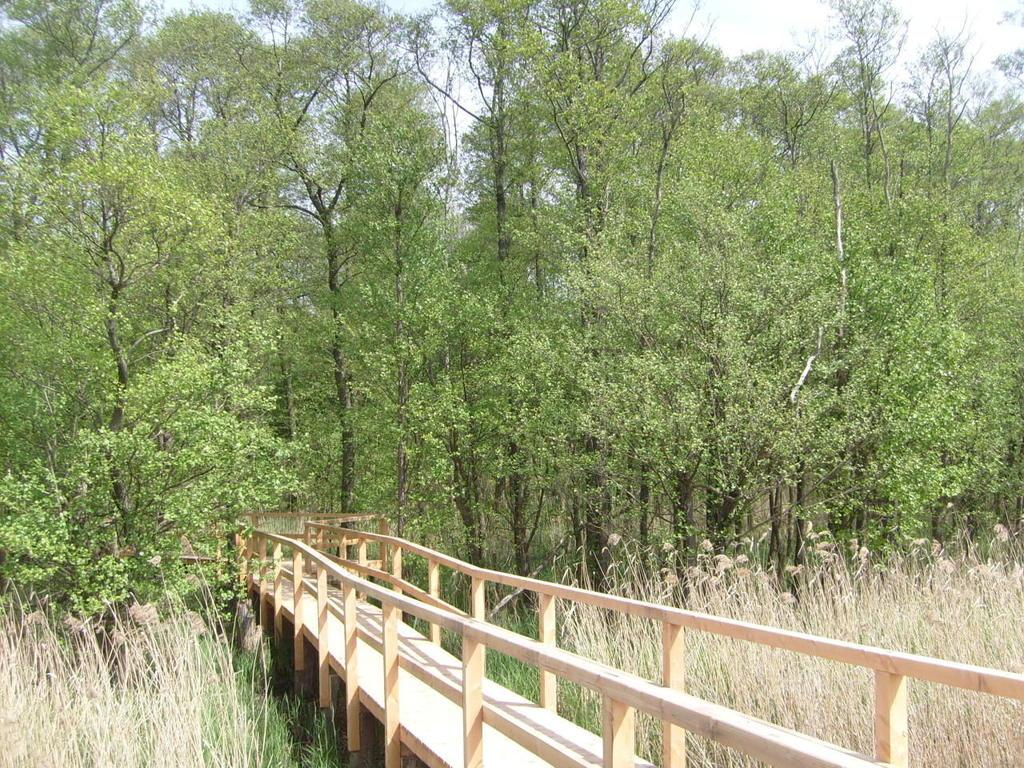What type of structure is present in the image? There is a wooden bridge in the image. What type of vegetation can be seen in the image? There are trees, grass, and plants in the image. What part of the natural environment is visible in the image? The sky is visible in the image. What type of stamp can be seen on the wooden bridge in the image? There is no stamp present on the wooden bridge in the image. 